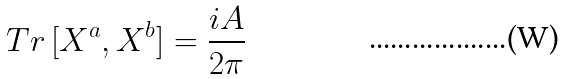Convert formula to latex. <formula><loc_0><loc_0><loc_500><loc_500>T r \, [ X ^ { a } , X ^ { b } ] = \frac { i A } { 2 \pi }</formula> 